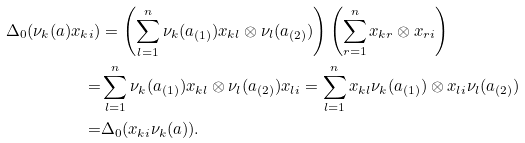Convert formula to latex. <formula><loc_0><loc_0><loc_500><loc_500>\Delta _ { 0 } ( \nu _ { k } ( a ) x _ { k i } ) & = \left ( \sum _ { l = 1 } ^ { n } \nu _ { k } ( a _ { ( 1 ) } ) x _ { k l } \otimes \nu _ { l } ( a _ { ( 2 ) } ) \right ) \left ( \sum _ { r = 1 } ^ { n } x _ { k r } \otimes x _ { r i } \right ) \\ = & \sum _ { l = 1 } ^ { n } \nu _ { k } ( a _ { ( 1 ) } ) x _ { k l } \otimes \nu _ { l } ( a _ { ( 2 ) } ) x _ { l i } = \sum _ { l = 1 } ^ { n } x _ { k l } \nu _ { k } ( a _ { ( 1 ) } ) \otimes x _ { l i } \nu _ { l } ( a _ { ( 2 ) } ) \\ = & \Delta _ { 0 } ( x _ { k i } \nu _ { k } ( a ) ) .</formula> 